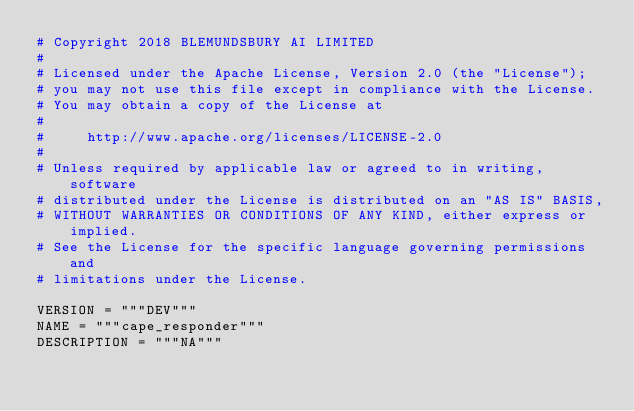<code> <loc_0><loc_0><loc_500><loc_500><_Python_># Copyright 2018 BLEMUNDSBURY AI LIMITED
#
# Licensed under the Apache License, Version 2.0 (the "License");
# you may not use this file except in compliance with the License.
# You may obtain a copy of the License at
#
#     http://www.apache.org/licenses/LICENSE-2.0
#
# Unless required by applicable law or agreed to in writing, software
# distributed under the License is distributed on an "AS IS" BASIS,
# WITHOUT WARRANTIES OR CONDITIONS OF ANY KIND, either express or implied.
# See the License for the specific language governing permissions and
# limitations under the License.

VERSION = """DEV"""
NAME = """cape_responder"""
DESCRIPTION = """NA"""
</code> 